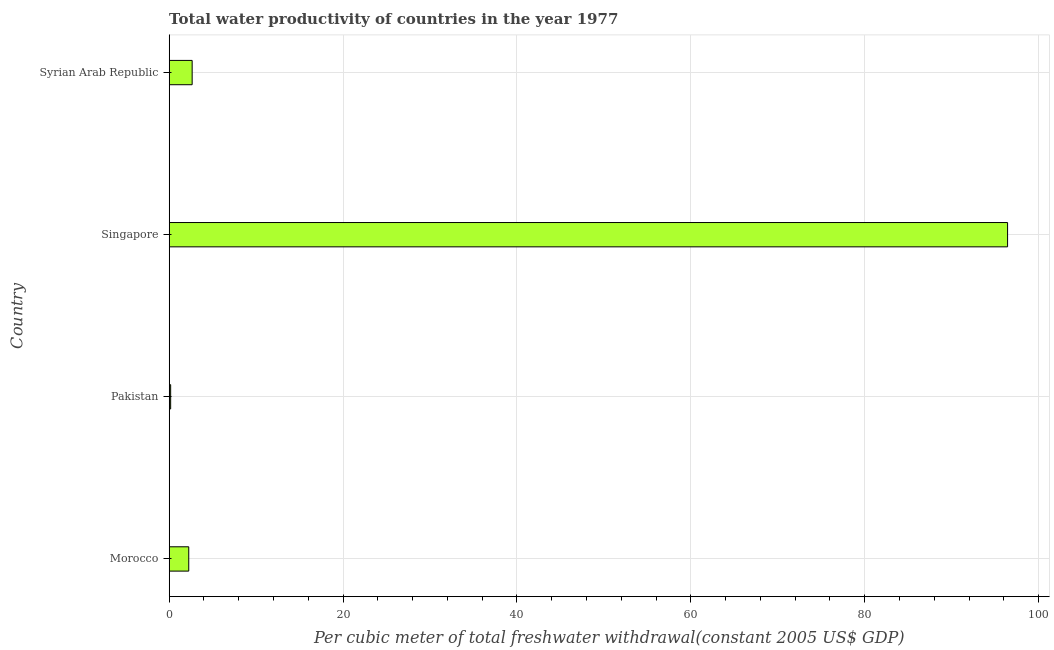Does the graph contain any zero values?
Provide a succinct answer. No. Does the graph contain grids?
Keep it short and to the point. Yes. What is the title of the graph?
Give a very brief answer. Total water productivity of countries in the year 1977. What is the label or title of the X-axis?
Offer a terse response. Per cubic meter of total freshwater withdrawal(constant 2005 US$ GDP). What is the label or title of the Y-axis?
Keep it short and to the point. Country. What is the total water productivity in Pakistan?
Keep it short and to the point. 0.17. Across all countries, what is the maximum total water productivity?
Give a very brief answer. 96.44. Across all countries, what is the minimum total water productivity?
Your response must be concise. 0.17. In which country was the total water productivity maximum?
Ensure brevity in your answer.  Singapore. What is the sum of the total water productivity?
Make the answer very short. 101.49. What is the difference between the total water productivity in Pakistan and Singapore?
Offer a very short reply. -96.27. What is the average total water productivity per country?
Give a very brief answer. 25.37. What is the median total water productivity?
Keep it short and to the point. 2.44. What is the ratio of the total water productivity in Pakistan to that in Singapore?
Ensure brevity in your answer.  0. Is the difference between the total water productivity in Morocco and Singapore greater than the difference between any two countries?
Offer a terse response. No. What is the difference between the highest and the second highest total water productivity?
Your answer should be very brief. 93.8. Is the sum of the total water productivity in Pakistan and Singapore greater than the maximum total water productivity across all countries?
Your answer should be compact. Yes. What is the difference between the highest and the lowest total water productivity?
Make the answer very short. 96.27. In how many countries, is the total water productivity greater than the average total water productivity taken over all countries?
Provide a succinct answer. 1. How many bars are there?
Your response must be concise. 4. Are all the bars in the graph horizontal?
Offer a very short reply. Yes. How many countries are there in the graph?
Offer a terse response. 4. What is the difference between two consecutive major ticks on the X-axis?
Ensure brevity in your answer.  20. Are the values on the major ticks of X-axis written in scientific E-notation?
Give a very brief answer. No. What is the Per cubic meter of total freshwater withdrawal(constant 2005 US$ GDP) in Morocco?
Make the answer very short. 2.25. What is the Per cubic meter of total freshwater withdrawal(constant 2005 US$ GDP) of Pakistan?
Your answer should be compact. 0.17. What is the Per cubic meter of total freshwater withdrawal(constant 2005 US$ GDP) of Singapore?
Provide a succinct answer. 96.44. What is the Per cubic meter of total freshwater withdrawal(constant 2005 US$ GDP) in Syrian Arab Republic?
Offer a terse response. 2.64. What is the difference between the Per cubic meter of total freshwater withdrawal(constant 2005 US$ GDP) in Morocco and Pakistan?
Make the answer very short. 2.08. What is the difference between the Per cubic meter of total freshwater withdrawal(constant 2005 US$ GDP) in Morocco and Singapore?
Provide a short and direct response. -94.19. What is the difference between the Per cubic meter of total freshwater withdrawal(constant 2005 US$ GDP) in Morocco and Syrian Arab Republic?
Provide a short and direct response. -0.39. What is the difference between the Per cubic meter of total freshwater withdrawal(constant 2005 US$ GDP) in Pakistan and Singapore?
Your answer should be very brief. -96.27. What is the difference between the Per cubic meter of total freshwater withdrawal(constant 2005 US$ GDP) in Pakistan and Syrian Arab Republic?
Your answer should be very brief. -2.47. What is the difference between the Per cubic meter of total freshwater withdrawal(constant 2005 US$ GDP) in Singapore and Syrian Arab Republic?
Give a very brief answer. 93.79. What is the ratio of the Per cubic meter of total freshwater withdrawal(constant 2005 US$ GDP) in Morocco to that in Pakistan?
Offer a terse response. 13.44. What is the ratio of the Per cubic meter of total freshwater withdrawal(constant 2005 US$ GDP) in Morocco to that in Singapore?
Offer a terse response. 0.02. What is the ratio of the Per cubic meter of total freshwater withdrawal(constant 2005 US$ GDP) in Morocco to that in Syrian Arab Republic?
Provide a succinct answer. 0.85. What is the ratio of the Per cubic meter of total freshwater withdrawal(constant 2005 US$ GDP) in Pakistan to that in Singapore?
Keep it short and to the point. 0. What is the ratio of the Per cubic meter of total freshwater withdrawal(constant 2005 US$ GDP) in Pakistan to that in Syrian Arab Republic?
Your answer should be very brief. 0.06. What is the ratio of the Per cubic meter of total freshwater withdrawal(constant 2005 US$ GDP) in Singapore to that in Syrian Arab Republic?
Offer a very short reply. 36.52. 